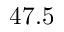<formula> <loc_0><loc_0><loc_500><loc_500>4 7 . 5</formula> 